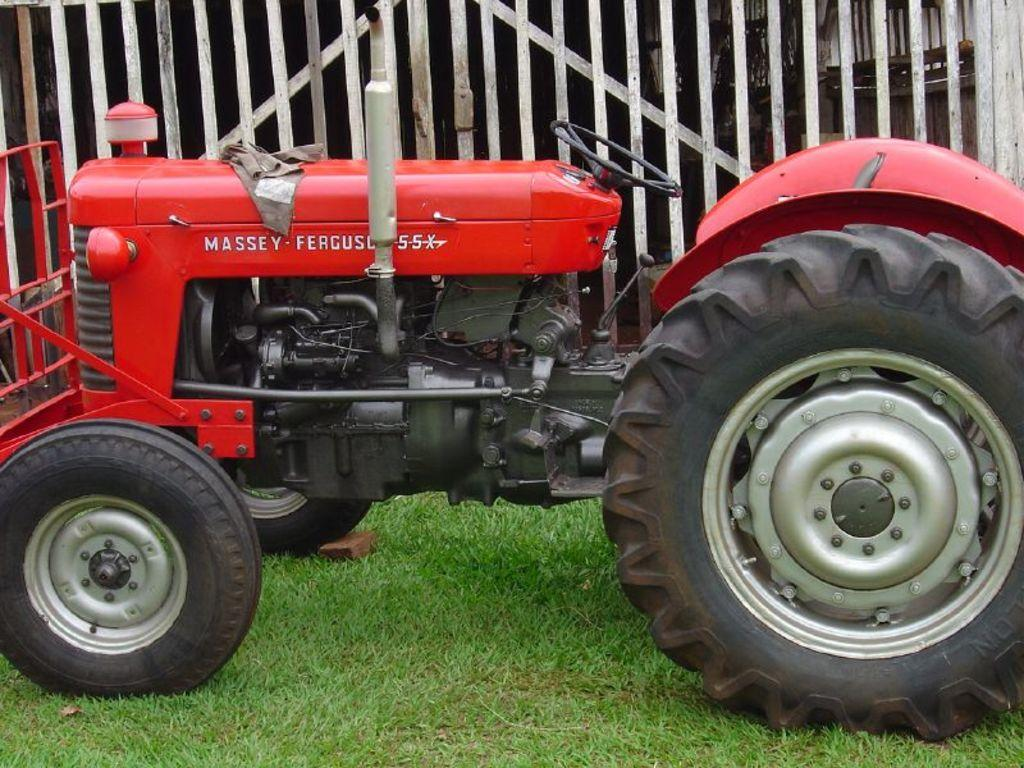What is the main subject in the center of the image? There is a tractor in the center of the image. What can be seen in the background of the image? There is a fence in the background of the image. What is visible at the bottom of the image? The ground is visible at the bottom of the image. What type of rod is being used to control the rate of the tractor in the image? There is no rod or mention of controlling the rate in the image; it simply shows a tractor in the center with a fence in the background and the ground visible at the bottom. 